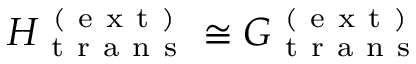Convert formula to latex. <formula><loc_0><loc_0><loc_500><loc_500>H _ { t r a n s } ^ { ( e x t ) } \cong G _ { t r a n s } ^ { ( e x t ) }</formula> 